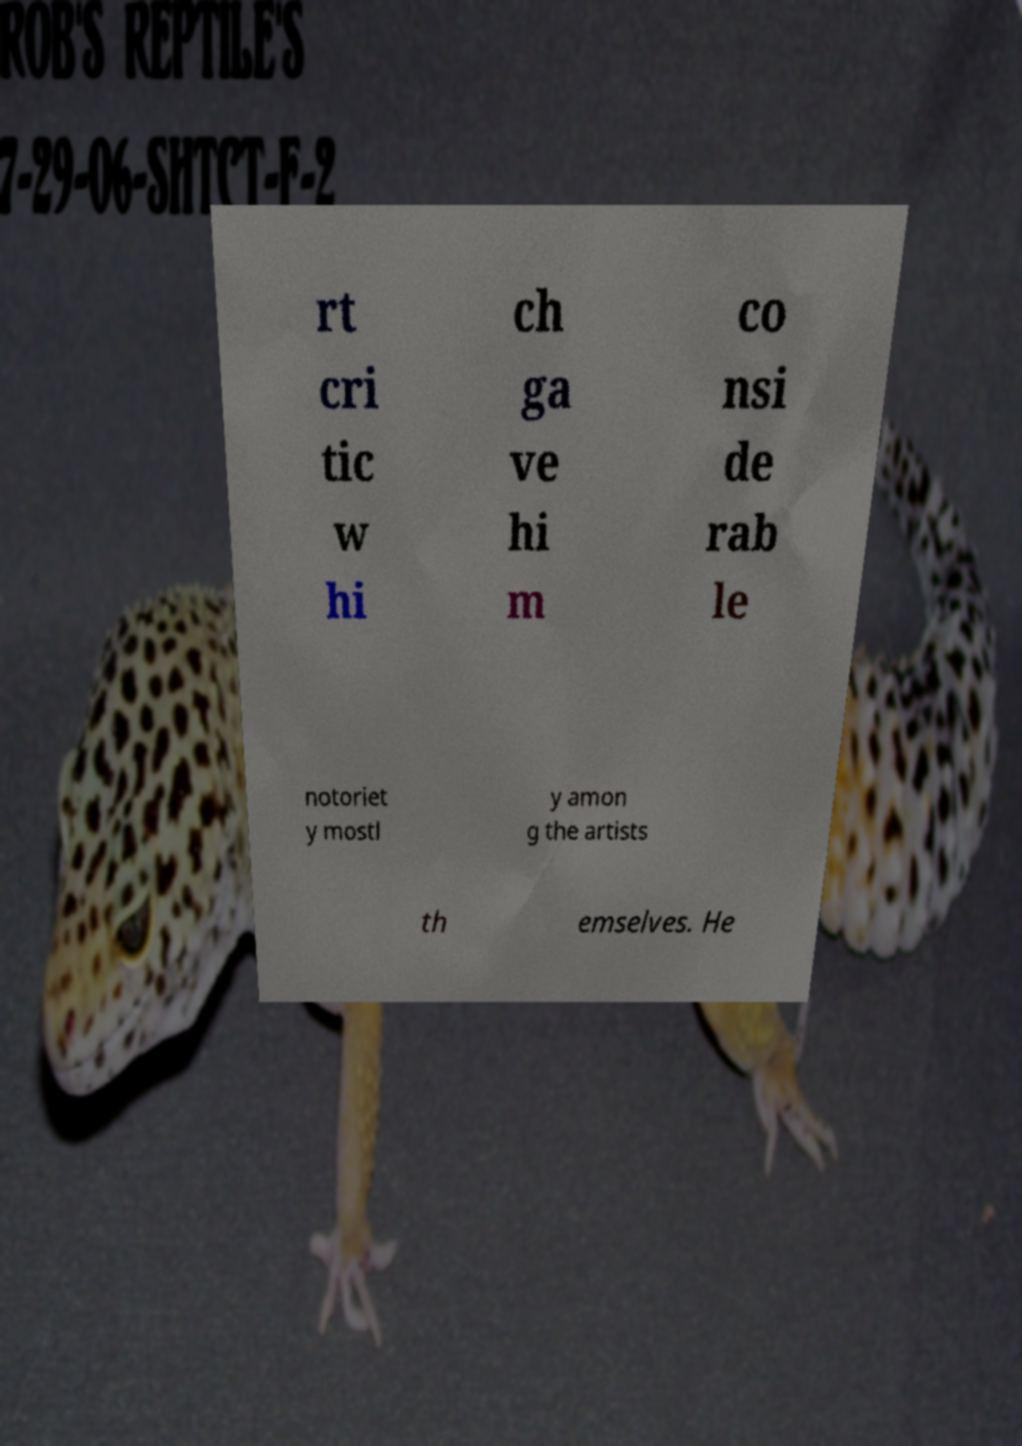Please read and relay the text visible in this image. What does it say? rt cri tic w hi ch ga ve hi m co nsi de rab le notoriet y mostl y amon g the artists th emselves. He 